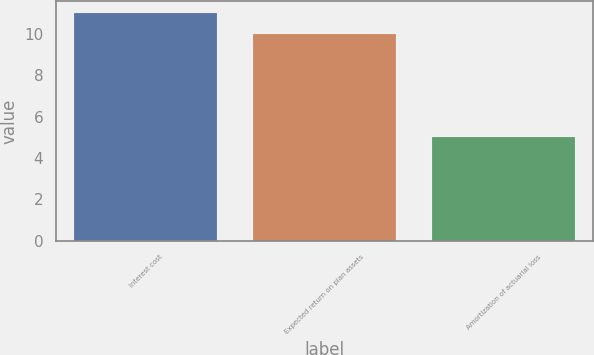Convert chart to OTSL. <chart><loc_0><loc_0><loc_500><loc_500><bar_chart><fcel>Interest cost<fcel>Expected return on plan assets<fcel>Amortization of actuarial loss<nl><fcel>11<fcel>10<fcel>5<nl></chart> 